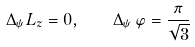Convert formula to latex. <formula><loc_0><loc_0><loc_500><loc_500>\Delta _ { \psi } L _ { z } = 0 , \quad \Delta _ { \psi } \, \varphi = \frac { \pi } { \sqrt { 3 } }</formula> 